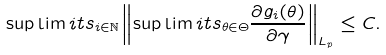<formula> <loc_0><loc_0><loc_500><loc_500>\sup \lim i t s _ { i \in \mathbb { N } } \left \| \sup \lim i t s _ { \theta \in \Theta } \frac { \partial g _ { i } ( \theta ) } { \partial \gamma } \right \| _ { L _ { p } } \leq C .</formula> 